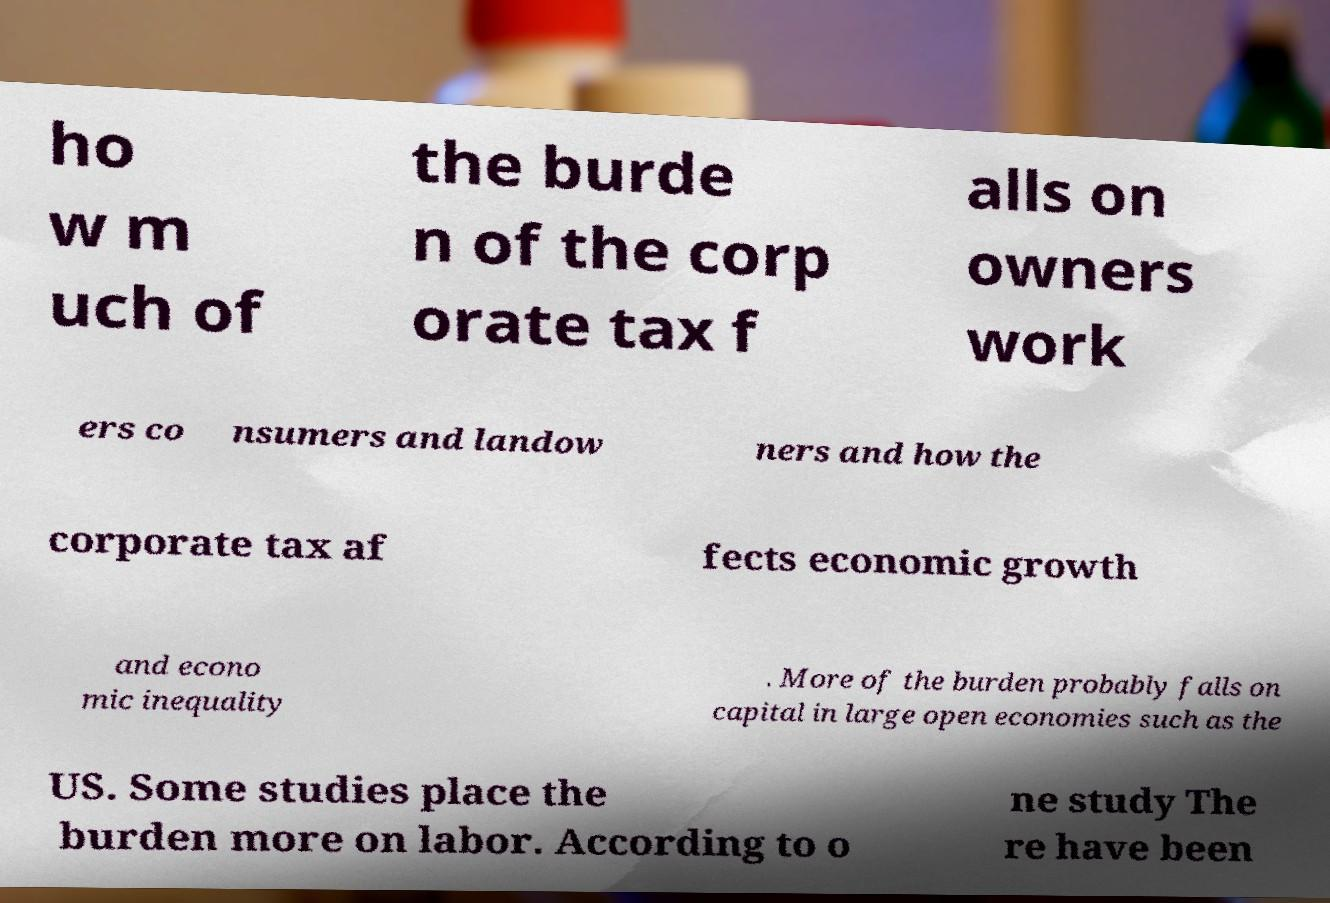For documentation purposes, I need the text within this image transcribed. Could you provide that? ho w m uch of the burde n of the corp orate tax f alls on owners work ers co nsumers and landow ners and how the corporate tax af fects economic growth and econo mic inequality . More of the burden probably falls on capital in large open economies such as the US. Some studies place the burden more on labor. According to o ne study The re have been 